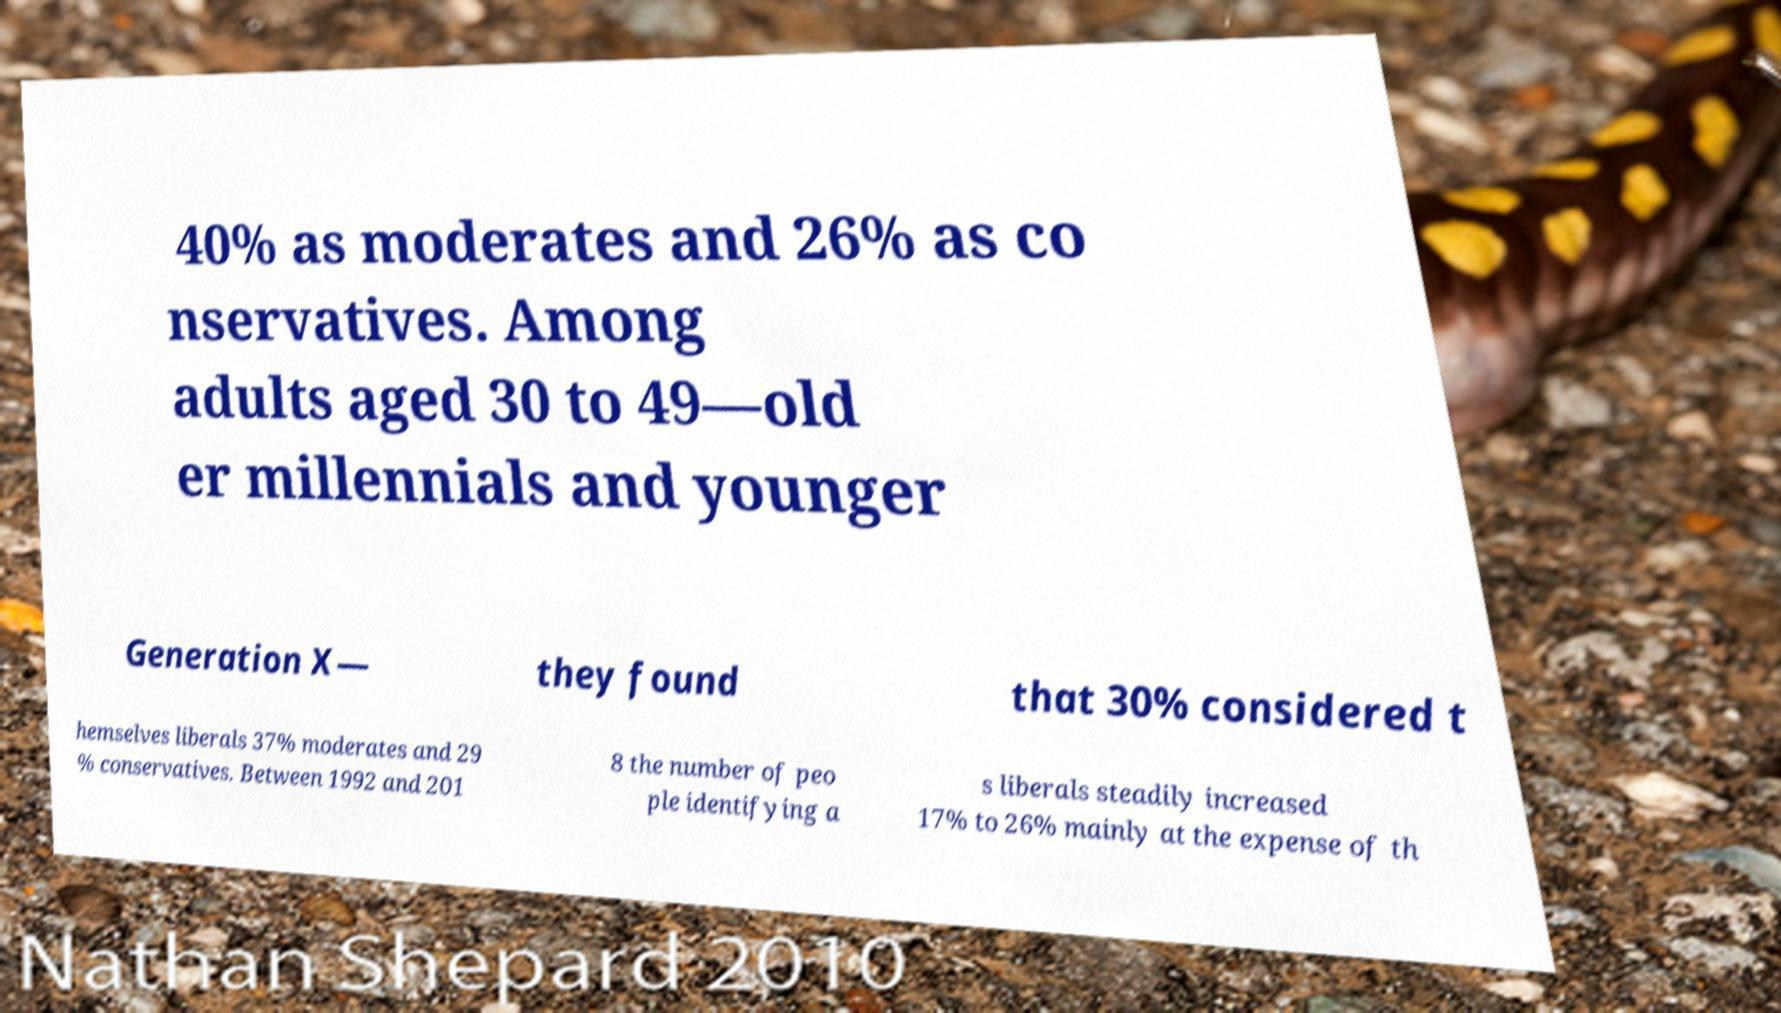What messages or text are displayed in this image? I need them in a readable, typed format. 40% as moderates and 26% as co nservatives. Among adults aged 30 to 49—old er millennials and younger Generation X— they found that 30% considered t hemselves liberals 37% moderates and 29 % conservatives. Between 1992 and 201 8 the number of peo ple identifying a s liberals steadily increased 17% to 26% mainly at the expense of th 